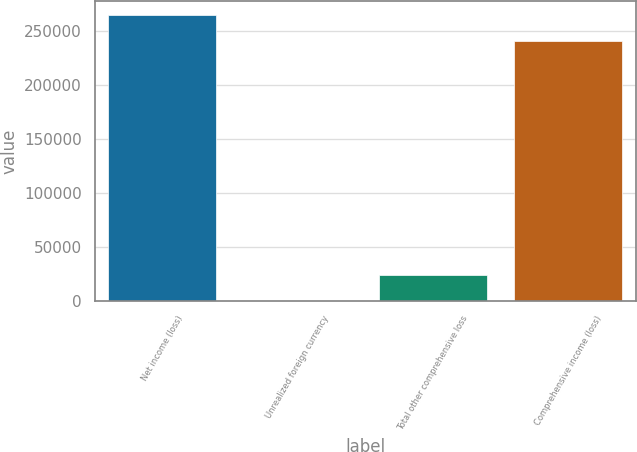Convert chart. <chart><loc_0><loc_0><loc_500><loc_500><bar_chart><fcel>Net income (loss)<fcel>Unrealized foreign currency<fcel>Total other comprehensive loss<fcel>Comprehensive income (loss)<nl><fcel>264621<fcel>109<fcel>24353.3<fcel>240377<nl></chart> 